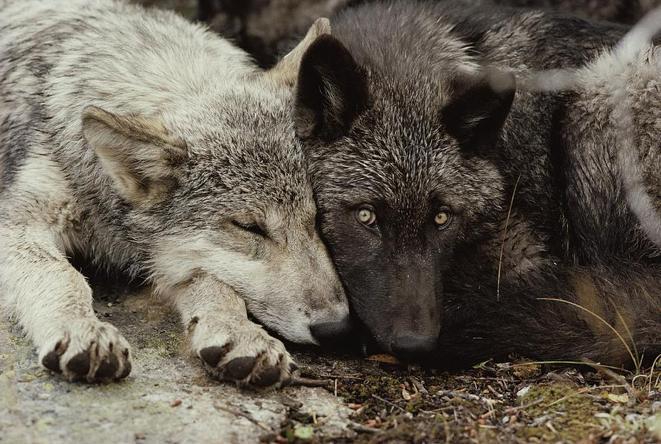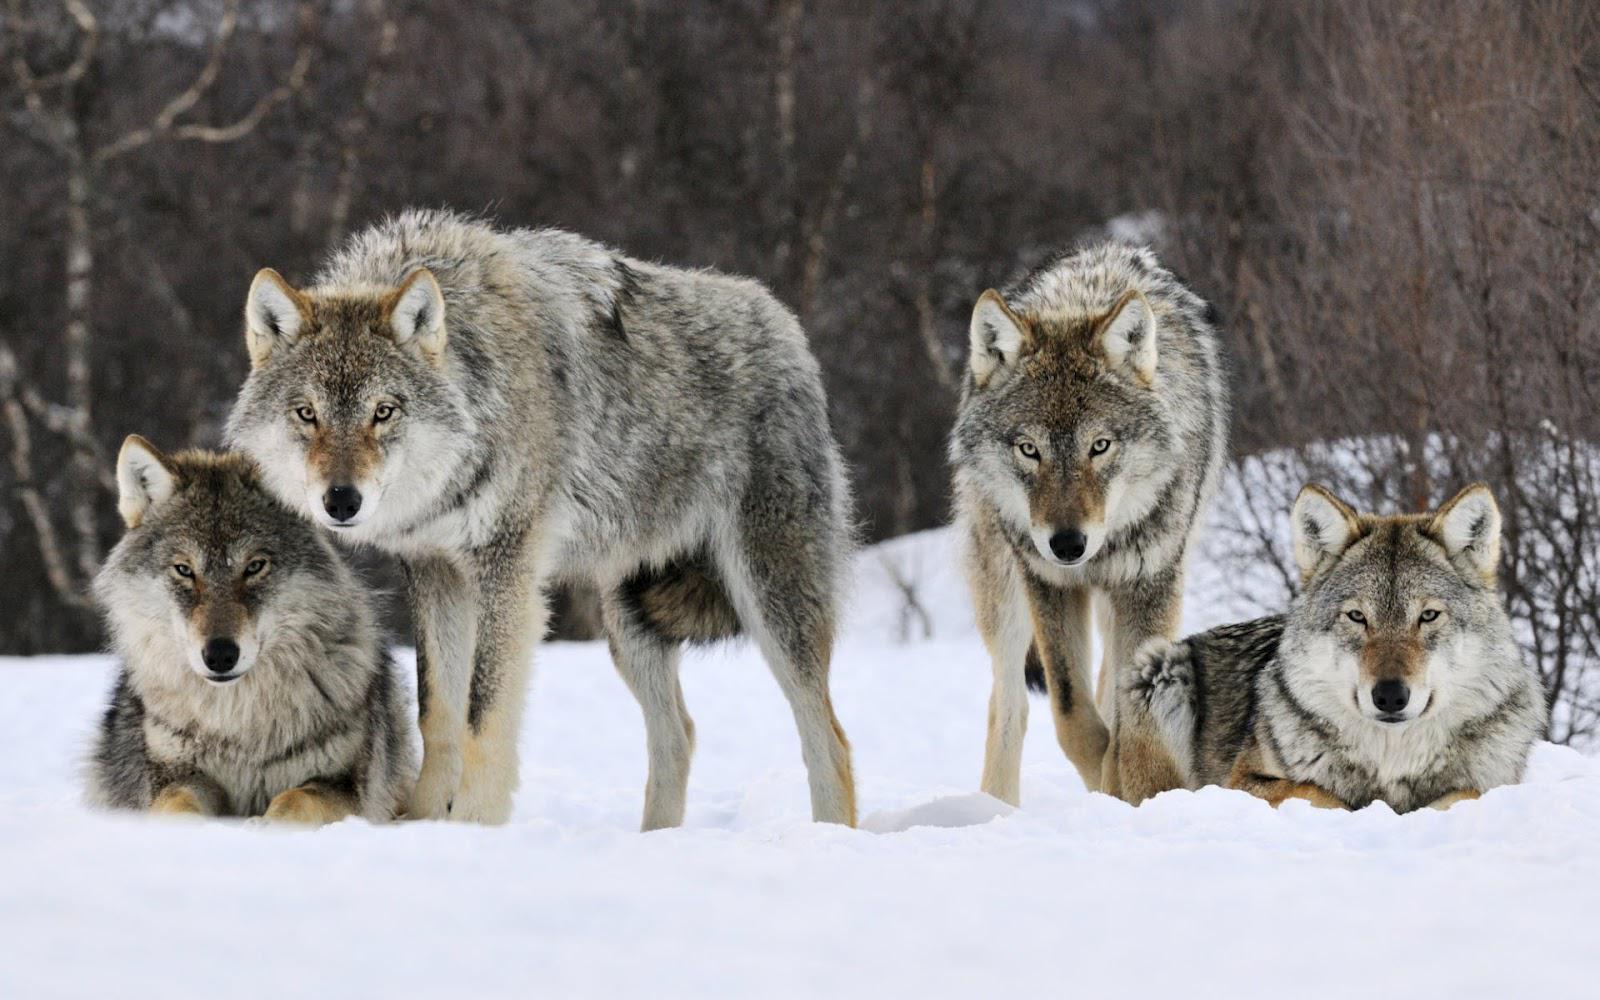The first image is the image on the left, the second image is the image on the right. Given the left and right images, does the statement "There are exactly 9 wolves." hold true? Answer yes or no. No. The first image is the image on the left, the second image is the image on the right. Assess this claim about the two images: "In the right image, there are four wolves in the snow.". Correct or not? Answer yes or no. Yes. 